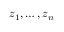<formula> <loc_0><loc_0><loc_500><loc_500>z _ { 1 } , \dots , z _ { n }</formula> 